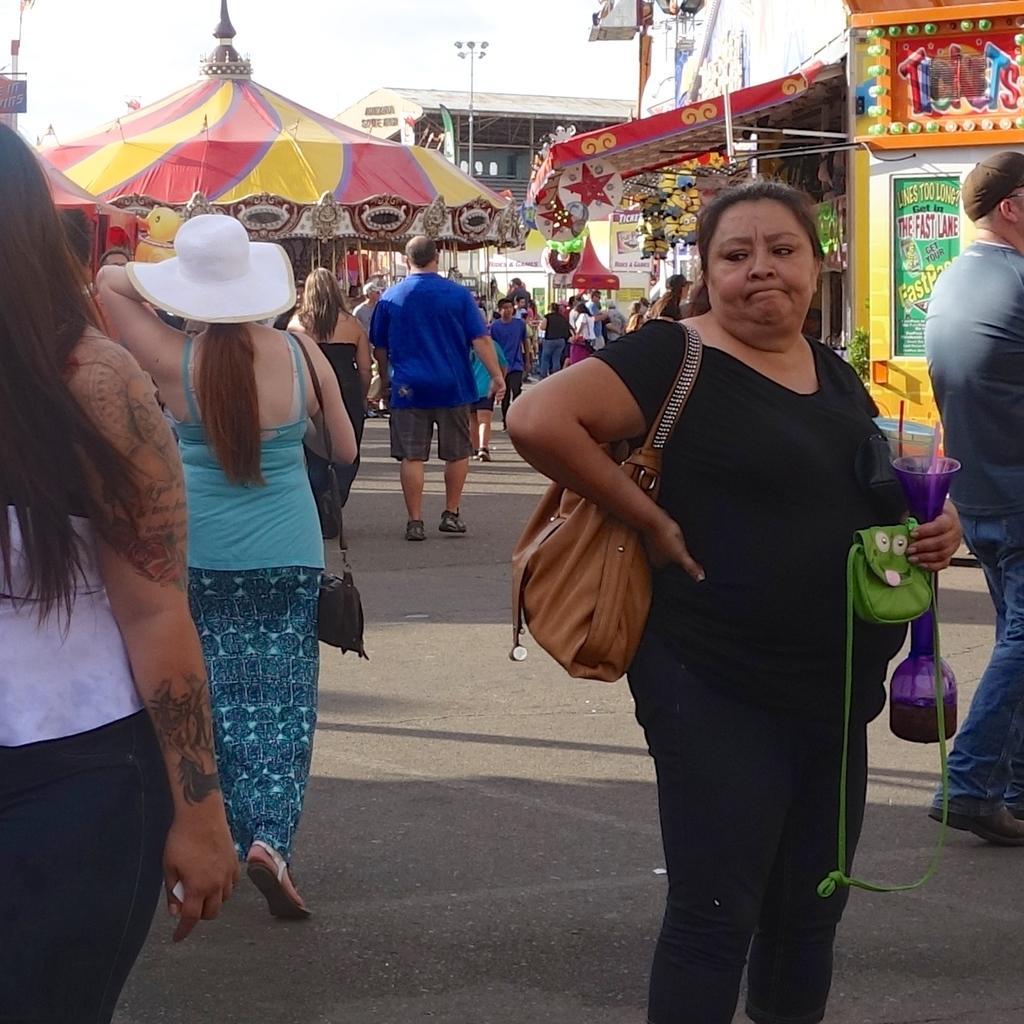Describe this image in one or two sentences. In this picture we can see a woman in the black dress is holding an object and a green bag. Behind the women there are groups of people walking. Behind the people there are stalls, a pole with lights and a sky. 